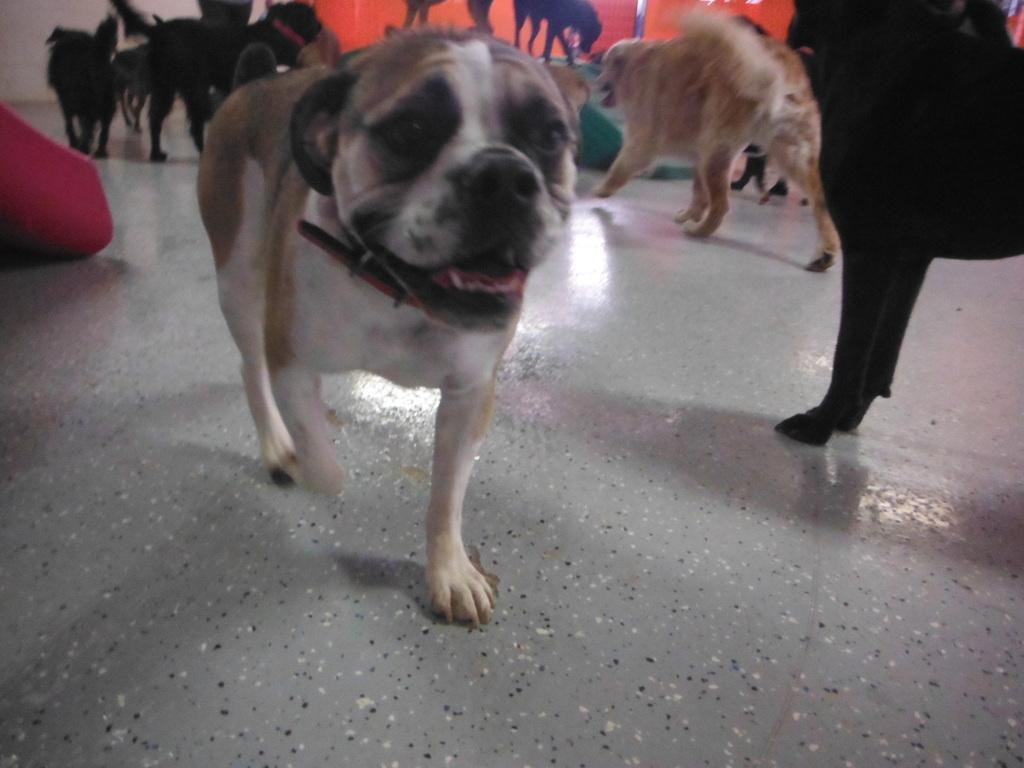What animals are present in the image? There are dogs in the image. What are the dogs doing in the image? The dogs are walking on the floor. What can be seen in the background of the image? There are orange color banners in the background of the image. What type of smoke can be seen coming from the dogs in the image? There is no smoke present in the image; it features dogs walking on the floor. What is the reaction of the dogs to the shock in the image? There is no shock present in the image, and the dogs' reactions cannot be determined. 